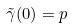<formula> <loc_0><loc_0><loc_500><loc_500>\tilde { \gamma } ( 0 ) = p</formula> 